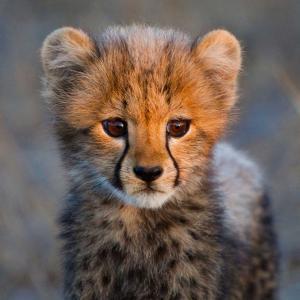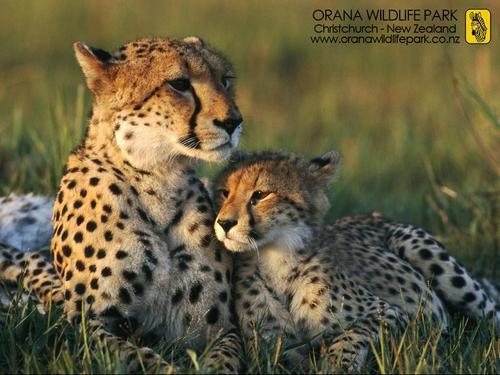The first image is the image on the left, the second image is the image on the right. Considering the images on both sides, is "The cheetah on the right image is a close up of its face while looking at the camera." valid? Answer yes or no. No. 